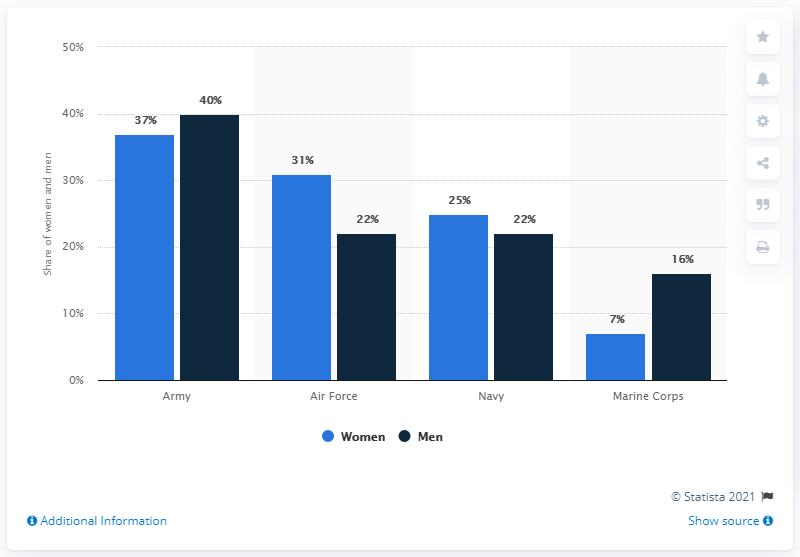Give some essential details in this illustration. It is evident that the Army branch has a higher proportion of shares among women and men. The share of women in the Air Force and Navy branches differs by a percentage point. 